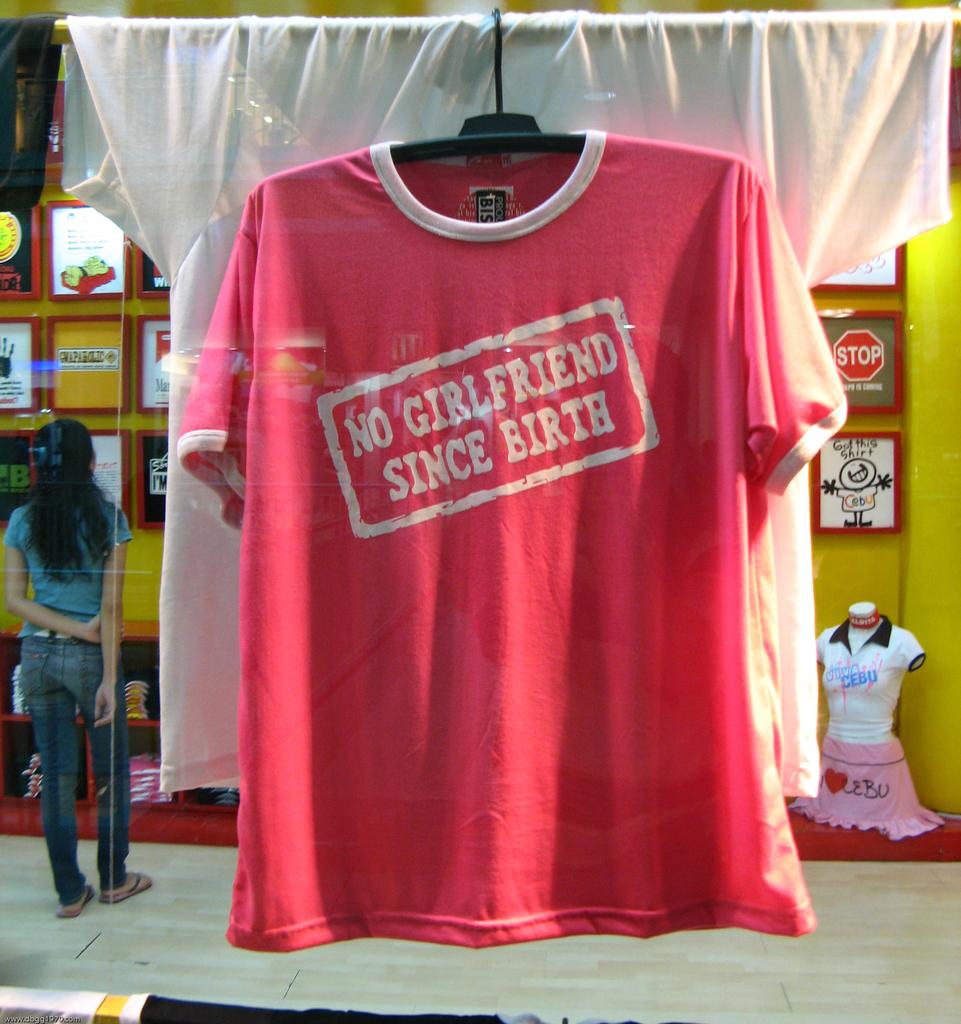What is written on this shirt?
Offer a terse response. No girlfriend since birth. What does the red sign in the back right say?
Your answer should be very brief. Stop. 